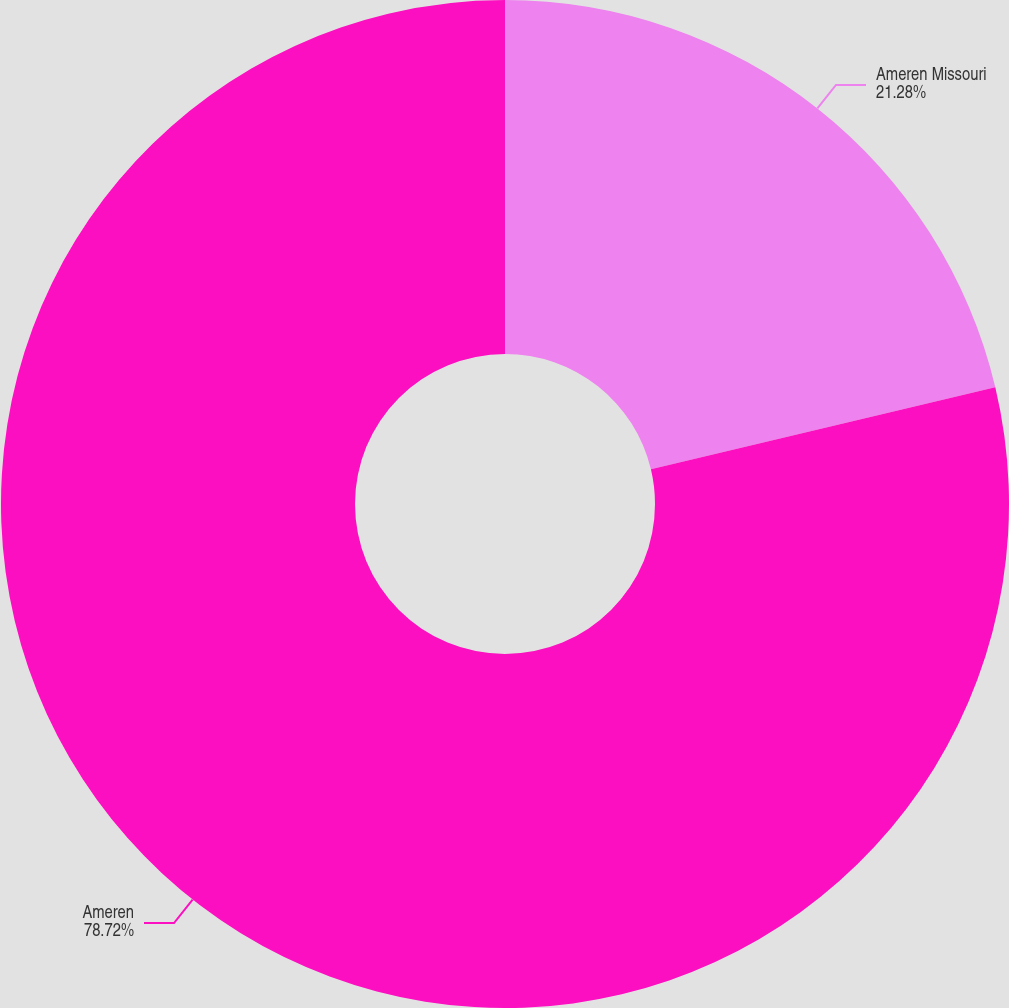Convert chart. <chart><loc_0><loc_0><loc_500><loc_500><pie_chart><fcel>Ameren Missouri<fcel>Ameren<nl><fcel>21.28%<fcel>78.72%<nl></chart> 